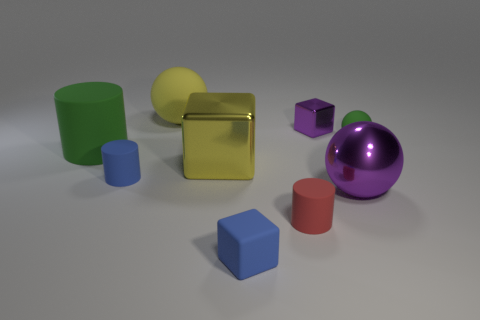How many shiny blocks have the same color as the small metal object?
Provide a short and direct response. 0. Is there a small blue matte thing?
Your answer should be compact. Yes. Does the large purple metal thing have the same shape as the thing in front of the small red rubber thing?
Keep it short and to the point. No. There is a large shiny object on the right side of the blue object in front of the purple object that is in front of the big green cylinder; what color is it?
Your answer should be compact. Purple. There is a small green ball; are there any small cylinders to the right of it?
Ensure brevity in your answer.  No. What size is the rubber sphere that is the same color as the big block?
Offer a terse response. Large. Are there any cylinders made of the same material as the big purple ball?
Give a very brief answer. No. The metallic ball has what color?
Provide a short and direct response. Purple. There is a blue thing that is behind the blue matte block; is its shape the same as the tiny green matte thing?
Ensure brevity in your answer.  No. There is a small thing to the right of the ball that is in front of the small cylinder to the left of the big matte sphere; what is its shape?
Provide a short and direct response. Sphere. 